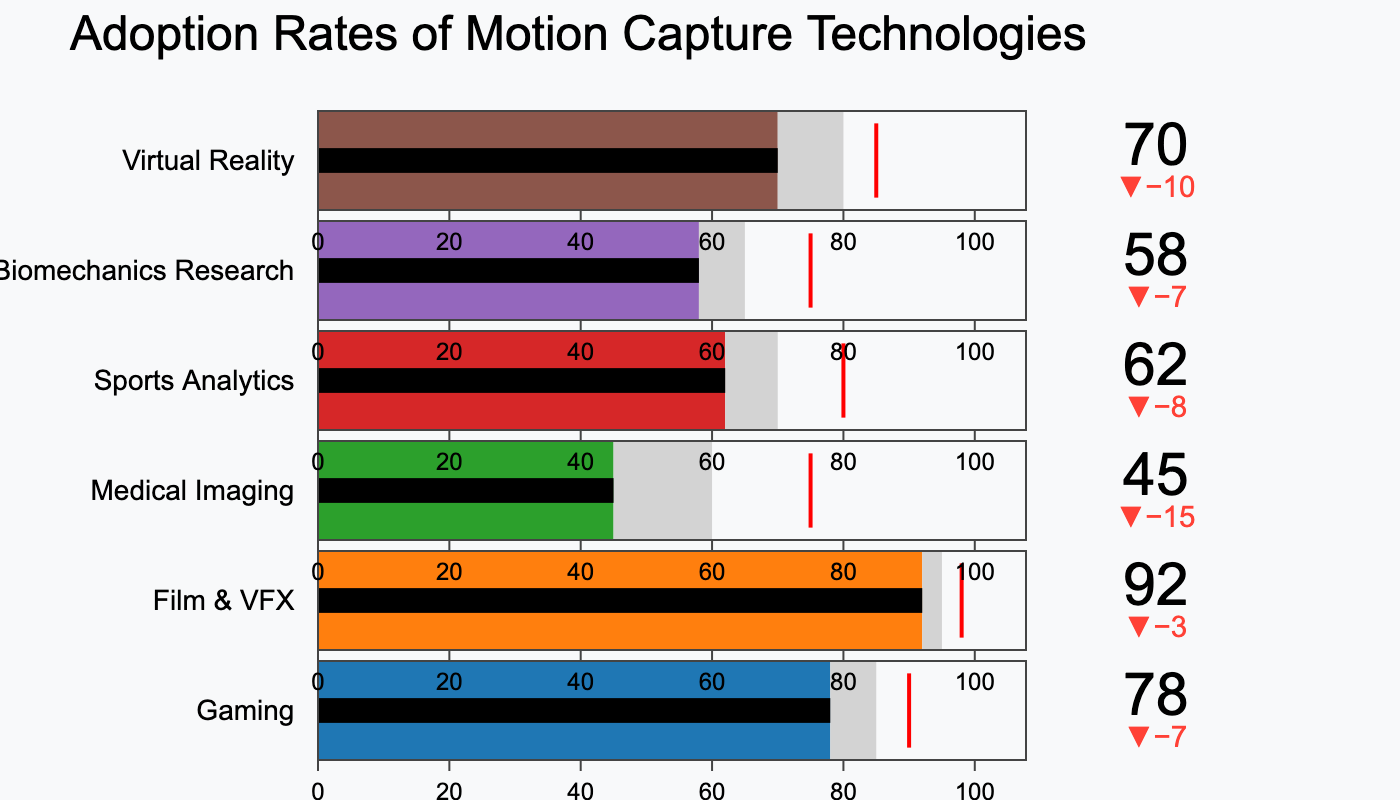Which industry has the highest actual adoption rate? The highest actual adoption rate can be found by looking at the bar that extends furthest to the right. The industry corresponding to that bar has the highest adoption rate.
Answer: Film & VFX What is the target adoption rate for the Medical Imaging industry? To find the target adoption rate for the Medical Imaging industry, locate the target value label next to the Medical Imaging bar.
Answer: 60 How much lower is the actual adoption rate compared to the target for the Sports Analytics industry? Subtract the actual adoption rate from the target adoption rate for the Sports Analytics industry (70 - 62).
Answer: 8 Which industry has the smallest difference between actual and target adoption rates? Calculate the differences for each industry and find the smallest one: (85-78), (95-92), (60-45), (70-62), (65-58), and (80-70). The smallest difference is 3 for Film & VFX.
Answer: Film & VFX How many industries have an actual adoption rate that exceeds their benchmark? Count the number of industries where the actual adoption rate bar extends beyond the benchmark marker.
Answer: 0 What is the average actual adoption rate across all industries shown? Sum all actual adoption rates (78 + 92 + 45 + 62 + 58 + 70) and divide by the number of industries (6). This yields (405/6).
Answer: 67.5 Which industry falls shortest of its benchmark, and by how much? For each industry, subtract the actual rate from the benchmark to find the industry with the largest value. Medical Imaging has the largest shortfall: (75 - 45).
Answer: Medical Imaging, 30 Between Gaming and Virtual Reality, which industry is closer to hitting its target adoption rate? Calculate the difference between the actual adoption rate and the target for both Gaming (85 - 78) and Virtual Reality (80 - 70), and compare. The smaller difference is for Virtual Reality.
Answer: Virtual Reality What is the benchmark adoption rate for Biomechanics Research? Locate the benchmark value label next to the Biomechanics Research bar in the chart.
Answer: 75 